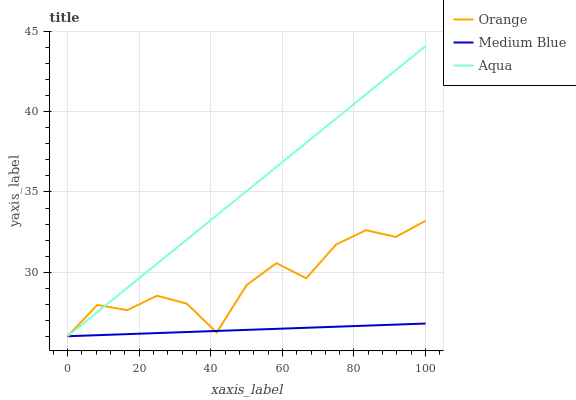Does Medium Blue have the minimum area under the curve?
Answer yes or no. Yes. Does Aqua have the maximum area under the curve?
Answer yes or no. Yes. Does Aqua have the minimum area under the curve?
Answer yes or no. No. Does Medium Blue have the maximum area under the curve?
Answer yes or no. No. Is Medium Blue the smoothest?
Answer yes or no. Yes. Is Orange the roughest?
Answer yes or no. Yes. Is Aqua the smoothest?
Answer yes or no. No. Is Aqua the roughest?
Answer yes or no. No. Does Orange have the lowest value?
Answer yes or no. Yes. Does Aqua have the highest value?
Answer yes or no. Yes. Does Medium Blue have the highest value?
Answer yes or no. No. Does Orange intersect Aqua?
Answer yes or no. Yes. Is Orange less than Aqua?
Answer yes or no. No. Is Orange greater than Aqua?
Answer yes or no. No. 